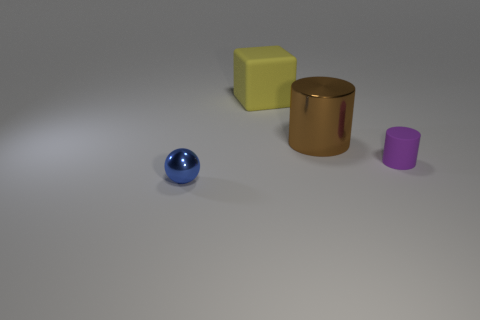Is the number of purple cylinders greater than the number of big matte cylinders?
Offer a very short reply. Yes. Is the material of the big object behind the brown thing the same as the tiny object to the right of the big matte cube?
Keep it short and to the point. Yes. What is the yellow thing made of?
Keep it short and to the point. Rubber. Are there more big metallic objects in front of the yellow rubber thing than yellow metal cylinders?
Your response must be concise. Yes. There is a matte object that is left of the large object that is to the right of the yellow cube; how many tiny cylinders are in front of it?
Give a very brief answer. 1. There is a thing that is left of the purple rubber object and right of the large yellow rubber cube; what is its material?
Your answer should be compact. Metal. The matte block is what color?
Your answer should be compact. Yellow. Are there more matte things that are behind the tiny metallic thing than cylinders that are behind the big brown object?
Offer a terse response. Yes. The tiny object to the right of the blue sphere is what color?
Your response must be concise. Purple. There is a shiny object that is to the right of the tiny blue sphere; is it the same size as the rubber object that is behind the big metal thing?
Provide a succinct answer. Yes. 